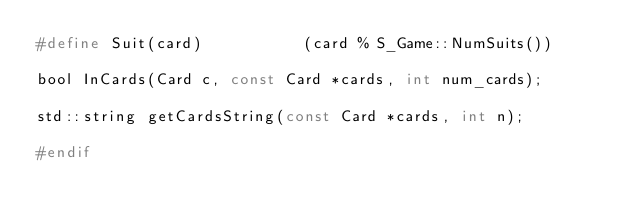<code> <loc_0><loc_0><loc_500><loc_500><_C_>#define Suit(card)           (card % S_Game::NumSuits())

bool InCards(Card c, const Card *cards, int num_cards);

std::string getCardsString(const Card *cards, int n);

#endif
</code> 